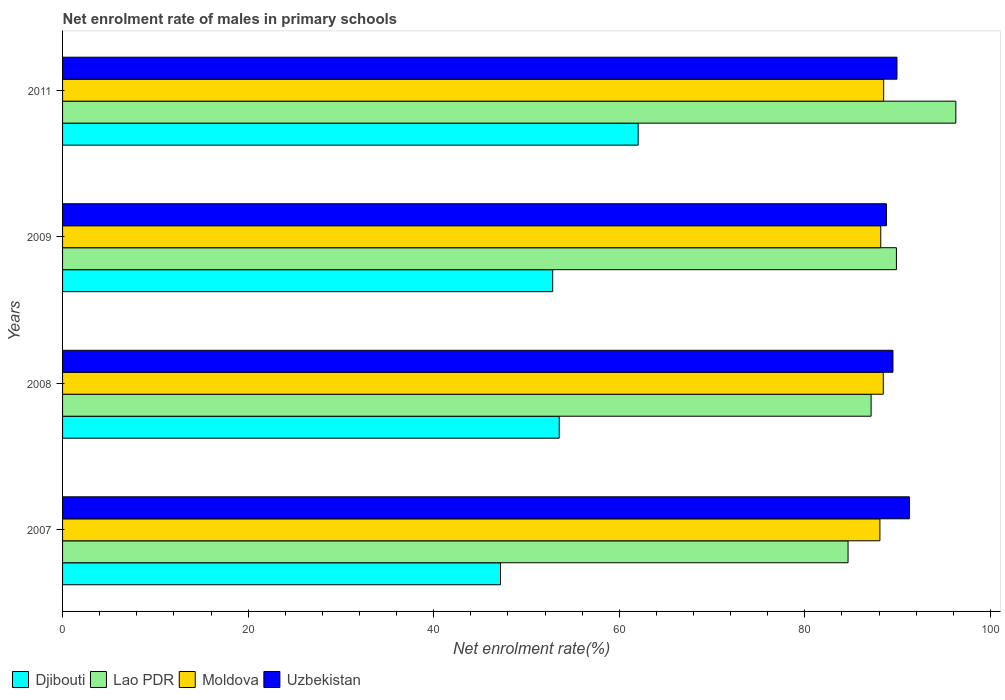What is the label of the 2nd group of bars from the top?
Give a very brief answer. 2009. What is the net enrolment rate of males in primary schools in Moldova in 2011?
Offer a terse response. 88.49. Across all years, what is the maximum net enrolment rate of males in primary schools in Djibouti?
Keep it short and to the point. 62.04. Across all years, what is the minimum net enrolment rate of males in primary schools in Uzbekistan?
Offer a very short reply. 88.79. In which year was the net enrolment rate of males in primary schools in Moldova maximum?
Keep it short and to the point. 2011. In which year was the net enrolment rate of males in primary schools in Djibouti minimum?
Give a very brief answer. 2007. What is the total net enrolment rate of males in primary schools in Uzbekistan in the graph?
Your response must be concise. 359.49. What is the difference between the net enrolment rate of males in primary schools in Lao PDR in 2008 and that in 2011?
Offer a terse response. -9.13. What is the difference between the net enrolment rate of males in primary schools in Moldova in 2008 and the net enrolment rate of males in primary schools in Uzbekistan in 2007?
Ensure brevity in your answer.  -2.82. What is the average net enrolment rate of males in primary schools in Djibouti per year?
Keep it short and to the point. 53.9. In the year 2008, what is the difference between the net enrolment rate of males in primary schools in Djibouti and net enrolment rate of males in primary schools in Moldova?
Ensure brevity in your answer.  -34.93. What is the ratio of the net enrolment rate of males in primary schools in Lao PDR in 2007 to that in 2008?
Your answer should be very brief. 0.97. Is the net enrolment rate of males in primary schools in Moldova in 2007 less than that in 2008?
Give a very brief answer. Yes. Is the difference between the net enrolment rate of males in primary schools in Djibouti in 2008 and 2009 greater than the difference between the net enrolment rate of males in primary schools in Moldova in 2008 and 2009?
Offer a terse response. Yes. What is the difference between the highest and the second highest net enrolment rate of males in primary schools in Djibouti?
Give a very brief answer. 8.51. What is the difference between the highest and the lowest net enrolment rate of males in primary schools in Moldova?
Your answer should be compact. 0.41. Is the sum of the net enrolment rate of males in primary schools in Lao PDR in 2007 and 2008 greater than the maximum net enrolment rate of males in primary schools in Djibouti across all years?
Offer a terse response. Yes. Is it the case that in every year, the sum of the net enrolment rate of males in primary schools in Uzbekistan and net enrolment rate of males in primary schools in Lao PDR is greater than the sum of net enrolment rate of males in primary schools in Djibouti and net enrolment rate of males in primary schools in Moldova?
Make the answer very short. No. What does the 2nd bar from the top in 2011 represents?
Your answer should be compact. Moldova. What does the 1st bar from the bottom in 2008 represents?
Make the answer very short. Djibouti. Is it the case that in every year, the sum of the net enrolment rate of males in primary schools in Djibouti and net enrolment rate of males in primary schools in Moldova is greater than the net enrolment rate of males in primary schools in Lao PDR?
Your answer should be very brief. Yes. How many bars are there?
Your response must be concise. 16. Are all the bars in the graph horizontal?
Provide a succinct answer. Yes. How many years are there in the graph?
Offer a very short reply. 4. What is the difference between two consecutive major ticks on the X-axis?
Provide a succinct answer. 20. Are the values on the major ticks of X-axis written in scientific E-notation?
Make the answer very short. No. Does the graph contain any zero values?
Provide a short and direct response. No. What is the title of the graph?
Provide a succinct answer. Net enrolment rate of males in primary schools. Does "Russian Federation" appear as one of the legend labels in the graph?
Offer a terse response. No. What is the label or title of the X-axis?
Make the answer very short. Net enrolment rate(%). What is the Net enrolment rate(%) of Djibouti in 2007?
Offer a terse response. 47.2. What is the Net enrolment rate(%) in Lao PDR in 2007?
Offer a very short reply. 84.66. What is the Net enrolment rate(%) of Moldova in 2007?
Your response must be concise. 88.09. What is the Net enrolment rate(%) in Uzbekistan in 2007?
Offer a very short reply. 91.28. What is the Net enrolment rate(%) of Djibouti in 2008?
Offer a terse response. 53.53. What is the Net enrolment rate(%) in Lao PDR in 2008?
Give a very brief answer. 87.14. What is the Net enrolment rate(%) of Moldova in 2008?
Offer a terse response. 88.45. What is the Net enrolment rate(%) of Uzbekistan in 2008?
Provide a short and direct response. 89.5. What is the Net enrolment rate(%) of Djibouti in 2009?
Your answer should be compact. 52.82. What is the Net enrolment rate(%) of Lao PDR in 2009?
Your answer should be compact. 89.87. What is the Net enrolment rate(%) in Moldova in 2009?
Offer a terse response. 88.18. What is the Net enrolment rate(%) of Uzbekistan in 2009?
Make the answer very short. 88.79. What is the Net enrolment rate(%) in Djibouti in 2011?
Your answer should be compact. 62.04. What is the Net enrolment rate(%) of Lao PDR in 2011?
Your response must be concise. 96.27. What is the Net enrolment rate(%) of Moldova in 2011?
Keep it short and to the point. 88.49. What is the Net enrolment rate(%) of Uzbekistan in 2011?
Give a very brief answer. 89.93. Across all years, what is the maximum Net enrolment rate(%) of Djibouti?
Give a very brief answer. 62.04. Across all years, what is the maximum Net enrolment rate(%) in Lao PDR?
Make the answer very short. 96.27. Across all years, what is the maximum Net enrolment rate(%) of Moldova?
Your answer should be very brief. 88.49. Across all years, what is the maximum Net enrolment rate(%) in Uzbekistan?
Your answer should be compact. 91.28. Across all years, what is the minimum Net enrolment rate(%) of Djibouti?
Keep it short and to the point. 47.2. Across all years, what is the minimum Net enrolment rate(%) in Lao PDR?
Give a very brief answer. 84.66. Across all years, what is the minimum Net enrolment rate(%) in Moldova?
Offer a very short reply. 88.09. Across all years, what is the minimum Net enrolment rate(%) of Uzbekistan?
Your answer should be compact. 88.79. What is the total Net enrolment rate(%) of Djibouti in the graph?
Ensure brevity in your answer.  215.59. What is the total Net enrolment rate(%) of Lao PDR in the graph?
Offer a very short reply. 357.94. What is the total Net enrolment rate(%) in Moldova in the graph?
Ensure brevity in your answer.  353.22. What is the total Net enrolment rate(%) of Uzbekistan in the graph?
Your answer should be very brief. 359.49. What is the difference between the Net enrolment rate(%) in Djibouti in 2007 and that in 2008?
Your response must be concise. -6.33. What is the difference between the Net enrolment rate(%) of Lao PDR in 2007 and that in 2008?
Provide a short and direct response. -2.48. What is the difference between the Net enrolment rate(%) of Moldova in 2007 and that in 2008?
Keep it short and to the point. -0.37. What is the difference between the Net enrolment rate(%) of Uzbekistan in 2007 and that in 2008?
Your answer should be very brief. 1.78. What is the difference between the Net enrolment rate(%) of Djibouti in 2007 and that in 2009?
Your answer should be very brief. -5.62. What is the difference between the Net enrolment rate(%) of Lao PDR in 2007 and that in 2009?
Provide a succinct answer. -5.21. What is the difference between the Net enrolment rate(%) in Moldova in 2007 and that in 2009?
Make the answer very short. -0.09. What is the difference between the Net enrolment rate(%) in Uzbekistan in 2007 and that in 2009?
Make the answer very short. 2.49. What is the difference between the Net enrolment rate(%) in Djibouti in 2007 and that in 2011?
Offer a terse response. -14.84. What is the difference between the Net enrolment rate(%) of Lao PDR in 2007 and that in 2011?
Make the answer very short. -11.62. What is the difference between the Net enrolment rate(%) of Moldova in 2007 and that in 2011?
Make the answer very short. -0.41. What is the difference between the Net enrolment rate(%) in Uzbekistan in 2007 and that in 2011?
Your answer should be compact. 1.35. What is the difference between the Net enrolment rate(%) in Djibouti in 2008 and that in 2009?
Provide a succinct answer. 0.7. What is the difference between the Net enrolment rate(%) of Lao PDR in 2008 and that in 2009?
Provide a short and direct response. -2.73. What is the difference between the Net enrolment rate(%) of Moldova in 2008 and that in 2009?
Make the answer very short. 0.27. What is the difference between the Net enrolment rate(%) of Uzbekistan in 2008 and that in 2009?
Your answer should be compact. 0.7. What is the difference between the Net enrolment rate(%) of Djibouti in 2008 and that in 2011?
Your answer should be compact. -8.51. What is the difference between the Net enrolment rate(%) in Lao PDR in 2008 and that in 2011?
Provide a short and direct response. -9.13. What is the difference between the Net enrolment rate(%) in Moldova in 2008 and that in 2011?
Your response must be concise. -0.04. What is the difference between the Net enrolment rate(%) in Uzbekistan in 2008 and that in 2011?
Keep it short and to the point. -0.43. What is the difference between the Net enrolment rate(%) of Djibouti in 2009 and that in 2011?
Your response must be concise. -9.21. What is the difference between the Net enrolment rate(%) of Lao PDR in 2009 and that in 2011?
Ensure brevity in your answer.  -6.4. What is the difference between the Net enrolment rate(%) of Moldova in 2009 and that in 2011?
Give a very brief answer. -0.31. What is the difference between the Net enrolment rate(%) of Uzbekistan in 2009 and that in 2011?
Offer a very short reply. -1.14. What is the difference between the Net enrolment rate(%) in Djibouti in 2007 and the Net enrolment rate(%) in Lao PDR in 2008?
Make the answer very short. -39.94. What is the difference between the Net enrolment rate(%) in Djibouti in 2007 and the Net enrolment rate(%) in Moldova in 2008?
Keep it short and to the point. -41.26. What is the difference between the Net enrolment rate(%) of Djibouti in 2007 and the Net enrolment rate(%) of Uzbekistan in 2008?
Your answer should be compact. -42.3. What is the difference between the Net enrolment rate(%) in Lao PDR in 2007 and the Net enrolment rate(%) in Moldova in 2008?
Provide a short and direct response. -3.8. What is the difference between the Net enrolment rate(%) of Lao PDR in 2007 and the Net enrolment rate(%) of Uzbekistan in 2008?
Your response must be concise. -4.84. What is the difference between the Net enrolment rate(%) of Moldova in 2007 and the Net enrolment rate(%) of Uzbekistan in 2008?
Provide a succinct answer. -1.41. What is the difference between the Net enrolment rate(%) in Djibouti in 2007 and the Net enrolment rate(%) in Lao PDR in 2009?
Your response must be concise. -42.67. What is the difference between the Net enrolment rate(%) in Djibouti in 2007 and the Net enrolment rate(%) in Moldova in 2009?
Your answer should be compact. -40.98. What is the difference between the Net enrolment rate(%) of Djibouti in 2007 and the Net enrolment rate(%) of Uzbekistan in 2009?
Give a very brief answer. -41.59. What is the difference between the Net enrolment rate(%) of Lao PDR in 2007 and the Net enrolment rate(%) of Moldova in 2009?
Make the answer very short. -3.52. What is the difference between the Net enrolment rate(%) of Lao PDR in 2007 and the Net enrolment rate(%) of Uzbekistan in 2009?
Keep it short and to the point. -4.13. What is the difference between the Net enrolment rate(%) in Moldova in 2007 and the Net enrolment rate(%) in Uzbekistan in 2009?
Provide a short and direct response. -0.7. What is the difference between the Net enrolment rate(%) in Djibouti in 2007 and the Net enrolment rate(%) in Lao PDR in 2011?
Provide a succinct answer. -49.07. What is the difference between the Net enrolment rate(%) of Djibouti in 2007 and the Net enrolment rate(%) of Moldova in 2011?
Keep it short and to the point. -41.3. What is the difference between the Net enrolment rate(%) of Djibouti in 2007 and the Net enrolment rate(%) of Uzbekistan in 2011?
Offer a very short reply. -42.73. What is the difference between the Net enrolment rate(%) of Lao PDR in 2007 and the Net enrolment rate(%) of Moldova in 2011?
Ensure brevity in your answer.  -3.84. What is the difference between the Net enrolment rate(%) of Lao PDR in 2007 and the Net enrolment rate(%) of Uzbekistan in 2011?
Your answer should be compact. -5.27. What is the difference between the Net enrolment rate(%) of Moldova in 2007 and the Net enrolment rate(%) of Uzbekistan in 2011?
Give a very brief answer. -1.84. What is the difference between the Net enrolment rate(%) of Djibouti in 2008 and the Net enrolment rate(%) of Lao PDR in 2009?
Ensure brevity in your answer.  -36.34. What is the difference between the Net enrolment rate(%) of Djibouti in 2008 and the Net enrolment rate(%) of Moldova in 2009?
Your response must be concise. -34.65. What is the difference between the Net enrolment rate(%) in Djibouti in 2008 and the Net enrolment rate(%) in Uzbekistan in 2009?
Offer a very short reply. -35.26. What is the difference between the Net enrolment rate(%) of Lao PDR in 2008 and the Net enrolment rate(%) of Moldova in 2009?
Provide a succinct answer. -1.04. What is the difference between the Net enrolment rate(%) of Lao PDR in 2008 and the Net enrolment rate(%) of Uzbekistan in 2009?
Make the answer very short. -1.65. What is the difference between the Net enrolment rate(%) of Moldova in 2008 and the Net enrolment rate(%) of Uzbekistan in 2009?
Provide a succinct answer. -0.34. What is the difference between the Net enrolment rate(%) in Djibouti in 2008 and the Net enrolment rate(%) in Lao PDR in 2011?
Offer a terse response. -42.74. What is the difference between the Net enrolment rate(%) of Djibouti in 2008 and the Net enrolment rate(%) of Moldova in 2011?
Your answer should be very brief. -34.97. What is the difference between the Net enrolment rate(%) of Djibouti in 2008 and the Net enrolment rate(%) of Uzbekistan in 2011?
Provide a short and direct response. -36.4. What is the difference between the Net enrolment rate(%) of Lao PDR in 2008 and the Net enrolment rate(%) of Moldova in 2011?
Ensure brevity in your answer.  -1.35. What is the difference between the Net enrolment rate(%) of Lao PDR in 2008 and the Net enrolment rate(%) of Uzbekistan in 2011?
Your answer should be very brief. -2.79. What is the difference between the Net enrolment rate(%) of Moldova in 2008 and the Net enrolment rate(%) of Uzbekistan in 2011?
Your answer should be very brief. -1.47. What is the difference between the Net enrolment rate(%) of Djibouti in 2009 and the Net enrolment rate(%) of Lao PDR in 2011?
Your response must be concise. -43.45. What is the difference between the Net enrolment rate(%) of Djibouti in 2009 and the Net enrolment rate(%) of Moldova in 2011?
Keep it short and to the point. -35.67. What is the difference between the Net enrolment rate(%) in Djibouti in 2009 and the Net enrolment rate(%) in Uzbekistan in 2011?
Offer a terse response. -37.1. What is the difference between the Net enrolment rate(%) of Lao PDR in 2009 and the Net enrolment rate(%) of Moldova in 2011?
Offer a very short reply. 1.37. What is the difference between the Net enrolment rate(%) of Lao PDR in 2009 and the Net enrolment rate(%) of Uzbekistan in 2011?
Your response must be concise. -0.06. What is the difference between the Net enrolment rate(%) of Moldova in 2009 and the Net enrolment rate(%) of Uzbekistan in 2011?
Give a very brief answer. -1.75. What is the average Net enrolment rate(%) in Djibouti per year?
Provide a succinct answer. 53.9. What is the average Net enrolment rate(%) of Lao PDR per year?
Make the answer very short. 89.48. What is the average Net enrolment rate(%) in Moldova per year?
Give a very brief answer. 88.3. What is the average Net enrolment rate(%) in Uzbekistan per year?
Your answer should be very brief. 89.87. In the year 2007, what is the difference between the Net enrolment rate(%) in Djibouti and Net enrolment rate(%) in Lao PDR?
Offer a very short reply. -37.46. In the year 2007, what is the difference between the Net enrolment rate(%) of Djibouti and Net enrolment rate(%) of Moldova?
Provide a short and direct response. -40.89. In the year 2007, what is the difference between the Net enrolment rate(%) of Djibouti and Net enrolment rate(%) of Uzbekistan?
Keep it short and to the point. -44.08. In the year 2007, what is the difference between the Net enrolment rate(%) of Lao PDR and Net enrolment rate(%) of Moldova?
Offer a terse response. -3.43. In the year 2007, what is the difference between the Net enrolment rate(%) of Lao PDR and Net enrolment rate(%) of Uzbekistan?
Keep it short and to the point. -6.62. In the year 2007, what is the difference between the Net enrolment rate(%) of Moldova and Net enrolment rate(%) of Uzbekistan?
Offer a very short reply. -3.19. In the year 2008, what is the difference between the Net enrolment rate(%) of Djibouti and Net enrolment rate(%) of Lao PDR?
Your response must be concise. -33.61. In the year 2008, what is the difference between the Net enrolment rate(%) of Djibouti and Net enrolment rate(%) of Moldova?
Ensure brevity in your answer.  -34.93. In the year 2008, what is the difference between the Net enrolment rate(%) of Djibouti and Net enrolment rate(%) of Uzbekistan?
Offer a terse response. -35.97. In the year 2008, what is the difference between the Net enrolment rate(%) of Lao PDR and Net enrolment rate(%) of Moldova?
Ensure brevity in your answer.  -1.31. In the year 2008, what is the difference between the Net enrolment rate(%) in Lao PDR and Net enrolment rate(%) in Uzbekistan?
Provide a succinct answer. -2.35. In the year 2008, what is the difference between the Net enrolment rate(%) of Moldova and Net enrolment rate(%) of Uzbekistan?
Offer a very short reply. -1.04. In the year 2009, what is the difference between the Net enrolment rate(%) of Djibouti and Net enrolment rate(%) of Lao PDR?
Offer a very short reply. -37.05. In the year 2009, what is the difference between the Net enrolment rate(%) of Djibouti and Net enrolment rate(%) of Moldova?
Keep it short and to the point. -35.36. In the year 2009, what is the difference between the Net enrolment rate(%) of Djibouti and Net enrolment rate(%) of Uzbekistan?
Keep it short and to the point. -35.97. In the year 2009, what is the difference between the Net enrolment rate(%) of Lao PDR and Net enrolment rate(%) of Moldova?
Provide a succinct answer. 1.69. In the year 2009, what is the difference between the Net enrolment rate(%) of Lao PDR and Net enrolment rate(%) of Uzbekistan?
Offer a terse response. 1.08. In the year 2009, what is the difference between the Net enrolment rate(%) of Moldova and Net enrolment rate(%) of Uzbekistan?
Keep it short and to the point. -0.61. In the year 2011, what is the difference between the Net enrolment rate(%) in Djibouti and Net enrolment rate(%) in Lao PDR?
Keep it short and to the point. -34.24. In the year 2011, what is the difference between the Net enrolment rate(%) of Djibouti and Net enrolment rate(%) of Moldova?
Make the answer very short. -26.46. In the year 2011, what is the difference between the Net enrolment rate(%) of Djibouti and Net enrolment rate(%) of Uzbekistan?
Keep it short and to the point. -27.89. In the year 2011, what is the difference between the Net enrolment rate(%) in Lao PDR and Net enrolment rate(%) in Moldova?
Make the answer very short. 7.78. In the year 2011, what is the difference between the Net enrolment rate(%) in Lao PDR and Net enrolment rate(%) in Uzbekistan?
Your answer should be compact. 6.34. In the year 2011, what is the difference between the Net enrolment rate(%) of Moldova and Net enrolment rate(%) of Uzbekistan?
Offer a terse response. -1.43. What is the ratio of the Net enrolment rate(%) in Djibouti in 2007 to that in 2008?
Provide a succinct answer. 0.88. What is the ratio of the Net enrolment rate(%) in Lao PDR in 2007 to that in 2008?
Provide a short and direct response. 0.97. What is the ratio of the Net enrolment rate(%) in Uzbekistan in 2007 to that in 2008?
Your answer should be very brief. 1.02. What is the ratio of the Net enrolment rate(%) of Djibouti in 2007 to that in 2009?
Your response must be concise. 0.89. What is the ratio of the Net enrolment rate(%) of Lao PDR in 2007 to that in 2009?
Your response must be concise. 0.94. What is the ratio of the Net enrolment rate(%) in Uzbekistan in 2007 to that in 2009?
Provide a short and direct response. 1.03. What is the ratio of the Net enrolment rate(%) in Djibouti in 2007 to that in 2011?
Your answer should be very brief. 0.76. What is the ratio of the Net enrolment rate(%) in Lao PDR in 2007 to that in 2011?
Offer a very short reply. 0.88. What is the ratio of the Net enrolment rate(%) in Moldova in 2007 to that in 2011?
Give a very brief answer. 1. What is the ratio of the Net enrolment rate(%) of Uzbekistan in 2007 to that in 2011?
Ensure brevity in your answer.  1.01. What is the ratio of the Net enrolment rate(%) of Djibouti in 2008 to that in 2009?
Offer a terse response. 1.01. What is the ratio of the Net enrolment rate(%) of Lao PDR in 2008 to that in 2009?
Offer a very short reply. 0.97. What is the ratio of the Net enrolment rate(%) of Moldova in 2008 to that in 2009?
Your response must be concise. 1. What is the ratio of the Net enrolment rate(%) in Uzbekistan in 2008 to that in 2009?
Make the answer very short. 1.01. What is the ratio of the Net enrolment rate(%) in Djibouti in 2008 to that in 2011?
Your answer should be compact. 0.86. What is the ratio of the Net enrolment rate(%) of Lao PDR in 2008 to that in 2011?
Ensure brevity in your answer.  0.91. What is the ratio of the Net enrolment rate(%) of Moldova in 2008 to that in 2011?
Ensure brevity in your answer.  1. What is the ratio of the Net enrolment rate(%) of Djibouti in 2009 to that in 2011?
Offer a terse response. 0.85. What is the ratio of the Net enrolment rate(%) in Lao PDR in 2009 to that in 2011?
Provide a short and direct response. 0.93. What is the ratio of the Net enrolment rate(%) of Uzbekistan in 2009 to that in 2011?
Your answer should be very brief. 0.99. What is the difference between the highest and the second highest Net enrolment rate(%) in Djibouti?
Your response must be concise. 8.51. What is the difference between the highest and the second highest Net enrolment rate(%) in Lao PDR?
Keep it short and to the point. 6.4. What is the difference between the highest and the second highest Net enrolment rate(%) in Moldova?
Make the answer very short. 0.04. What is the difference between the highest and the second highest Net enrolment rate(%) of Uzbekistan?
Provide a short and direct response. 1.35. What is the difference between the highest and the lowest Net enrolment rate(%) in Djibouti?
Give a very brief answer. 14.84. What is the difference between the highest and the lowest Net enrolment rate(%) of Lao PDR?
Provide a succinct answer. 11.62. What is the difference between the highest and the lowest Net enrolment rate(%) of Moldova?
Give a very brief answer. 0.41. What is the difference between the highest and the lowest Net enrolment rate(%) of Uzbekistan?
Your response must be concise. 2.49. 